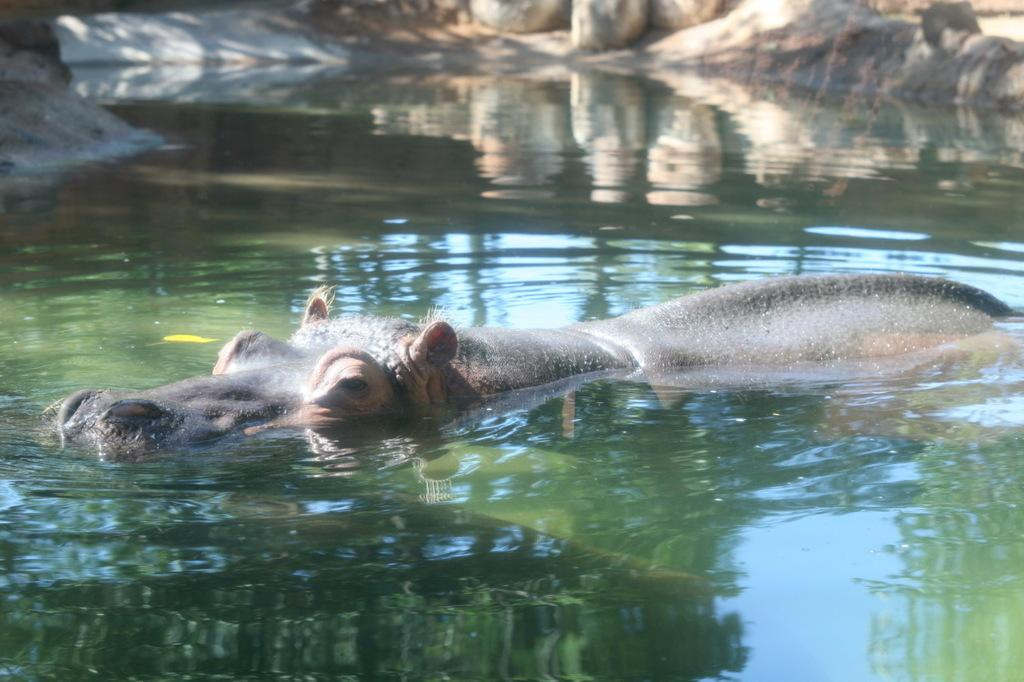What animal is in the image? There is a hippopotamus in the image. Where is the hippopotamus located? The hippopotamus is in the water. What else can be seen in the image besides the hippopotamus? There are stones visible in the image. How many cherries can be seen on the cat in the image? There is no cat or cherries present in the image; it features a hippopotamus in the water and stones. 